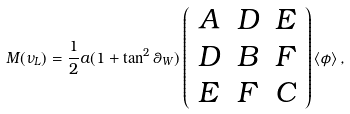<formula> <loc_0><loc_0><loc_500><loc_500>M ( \nu _ { L } ) = \frac { 1 } { 2 } a ( 1 + \tan ^ { 2 } \theta _ { W } ) \left ( \begin{array} { c c c } A & D & E \\ D & B & F \\ E & F & C \end{array} \right ) \left \langle \phi \right \rangle ,</formula> 